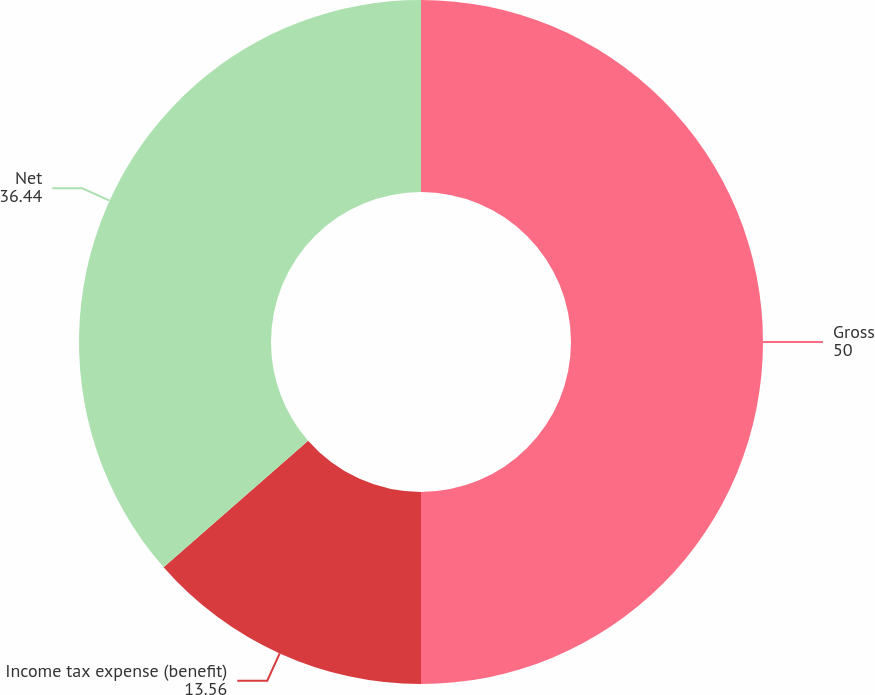<chart> <loc_0><loc_0><loc_500><loc_500><pie_chart><fcel>Gross<fcel>Income tax expense (benefit)<fcel>Net<nl><fcel>50.0%<fcel>13.56%<fcel>36.44%<nl></chart> 